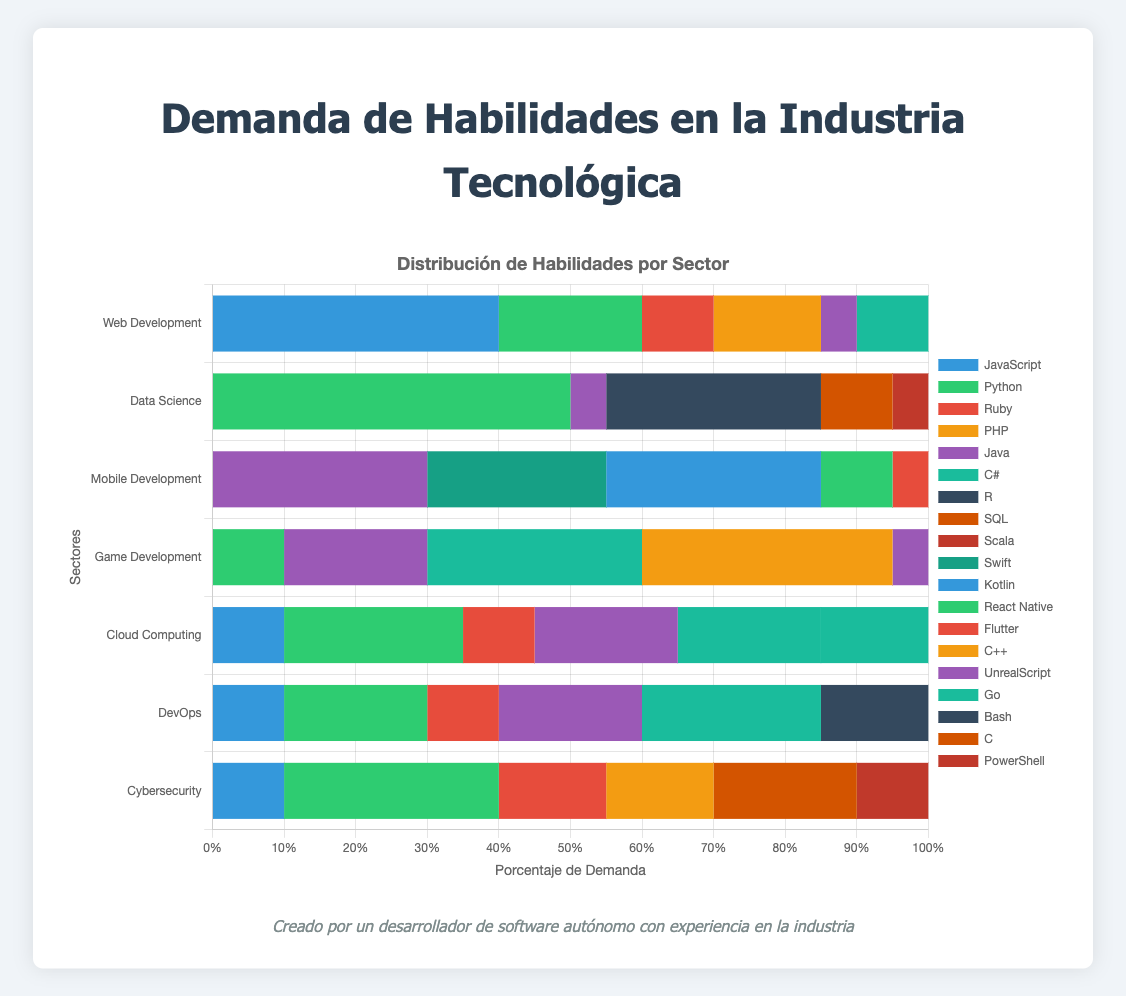Which sector has the highest demand for JavaScript? To find the sector with the highest demand for JavaScript, look at the lengths of the JavaScript sections in the stacked bars. Web Development has the longest JavaScript bar with a demand of 40%.
Answer: Web Development What is the total demand for Python across all sectors? Find the demand for Python in each sector and add them up: Web Development (20) + Data Science (50) + Mobile Development (0) + Game Development (10) + Cloud Computing (25) + DevOps (20) + Cybersecurity (30) = 155%.
Answer: 155 Which sector has the least demand for Ruby? Compare the Ruby segments in each sector's bar. Web Development (10), Data Science (0), Mobile Development (0), Game Development (0), Cloud Computing (10), DevOps (10), Cybersecurity (15). Data Science, Mobile Development, and Game Development have no demand for Ruby, so they are the sectors with the least demand.
Answer: Data Science, Mobile Development, Game Development Is the demand for Java higher in Cloud Computing or Game Development? Look at the lengths of the Java segments in Cloud Computing and Game Development. Cloud Computing has a Java demand of 20%, while Game Development has a Java demand of 20%.
Answer: Equal Which sector has the greatest variety of programming languages in demand? Identify the number of different languages listed for each sector: Web Development (6), Data Science (5), Mobile Development (5), Game Development (5), Cloud Computing (6), DevOps (6), Cybersecurity (6). The sectors with the greatest variety are those with the most languages listed.
Answer: Web Development, Cloud Computing, DevOps, Cybersecurity What is the combined demand for Go across Cloud Computing and DevOps? Sum the demands for Go in Cloud Computing and DevOps. Cloud Computing has 15% and DevOps has 25%, so the total is 15 + 25 = 40%.
Answer: 40 Which sector shows the highest demand for a single language, and what is the language? Identify the highest percentage value in any sector for any language. Data Science has a 50% demand for Python, which is the highest single-language demand across sectors.
Answer: Data Science, Python 